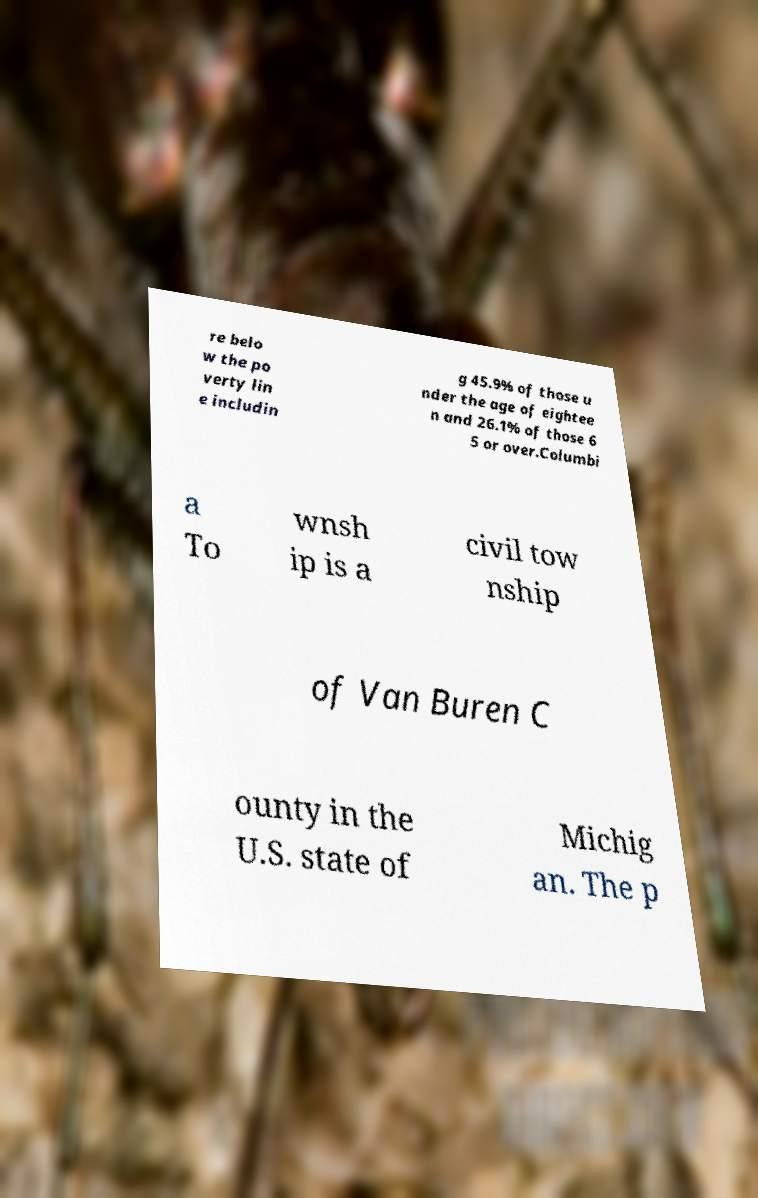Can you read and provide the text displayed in the image?This photo seems to have some interesting text. Can you extract and type it out for me? re belo w the po verty lin e includin g 45.9% of those u nder the age of eightee n and 26.1% of those 6 5 or over.Columbi a To wnsh ip is a civil tow nship of Van Buren C ounty in the U.S. state of Michig an. The p 